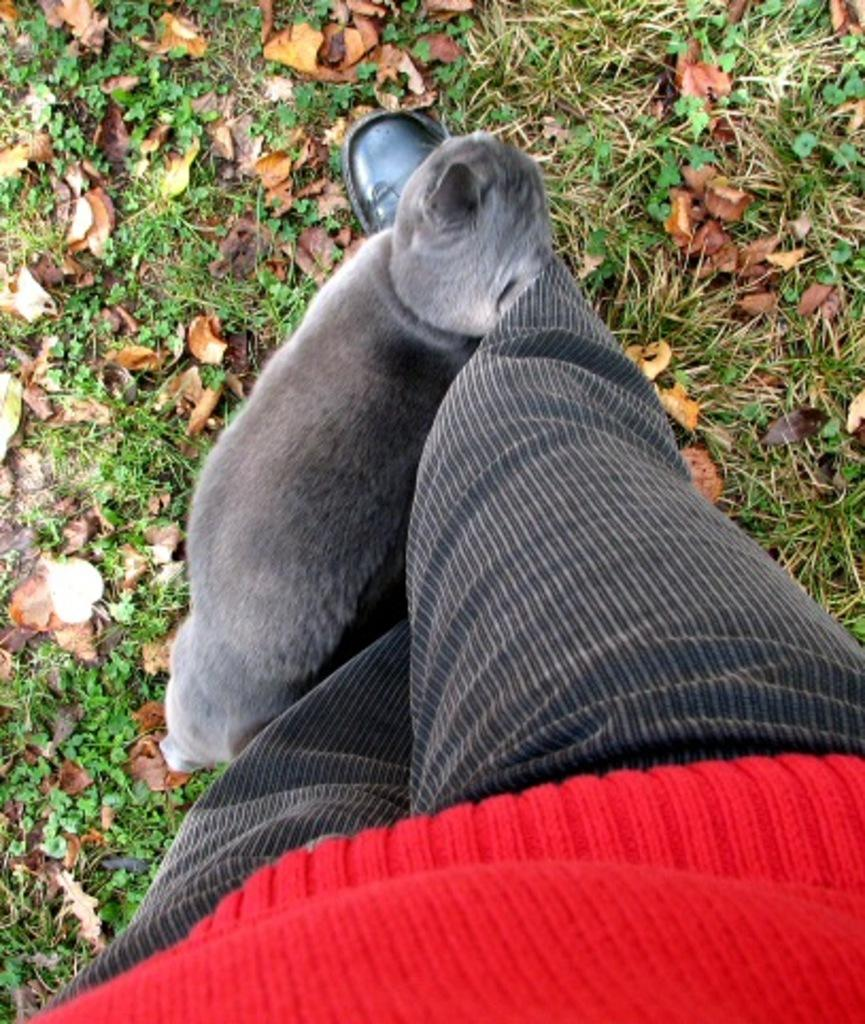What object can be seen in the image that is typically worn on the foot? There is a shoe in the image. What part of a person's body is visible in the image? A leg of a person is visible in the image. What color is the top that is visible in the image? There is a red top in the image. What type of living creature is present near the person's leg? An animal is present near the person's leg. What type of roof can be seen in the image? There is no roof present in the image. How much money is visible in the image? There is no money visible in the image. 